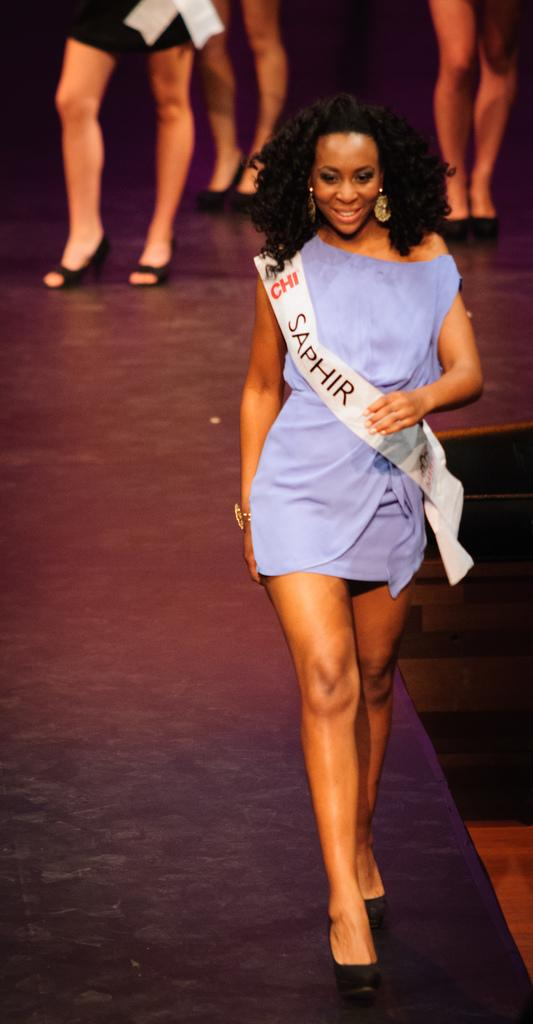<image>
Offer a succinct explanation of the picture presented. Lady walking on a runway with a banner across her that has SAPHIR in black letters. 